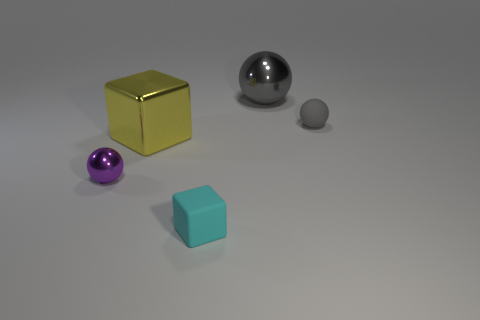Subtract all big spheres. How many spheres are left? 2 Add 1 matte spheres. How many objects exist? 6 Subtract all blue blocks. How many gray spheres are left? 2 Subtract 3 balls. How many balls are left? 0 Subtract all balls. How many objects are left? 2 Add 1 small gray matte things. How many small gray matte things are left? 2 Add 2 small brown blocks. How many small brown blocks exist? 2 Subtract all purple spheres. How many spheres are left? 2 Subtract 0 brown cubes. How many objects are left? 5 Subtract all blue cubes. Subtract all purple balls. How many cubes are left? 2 